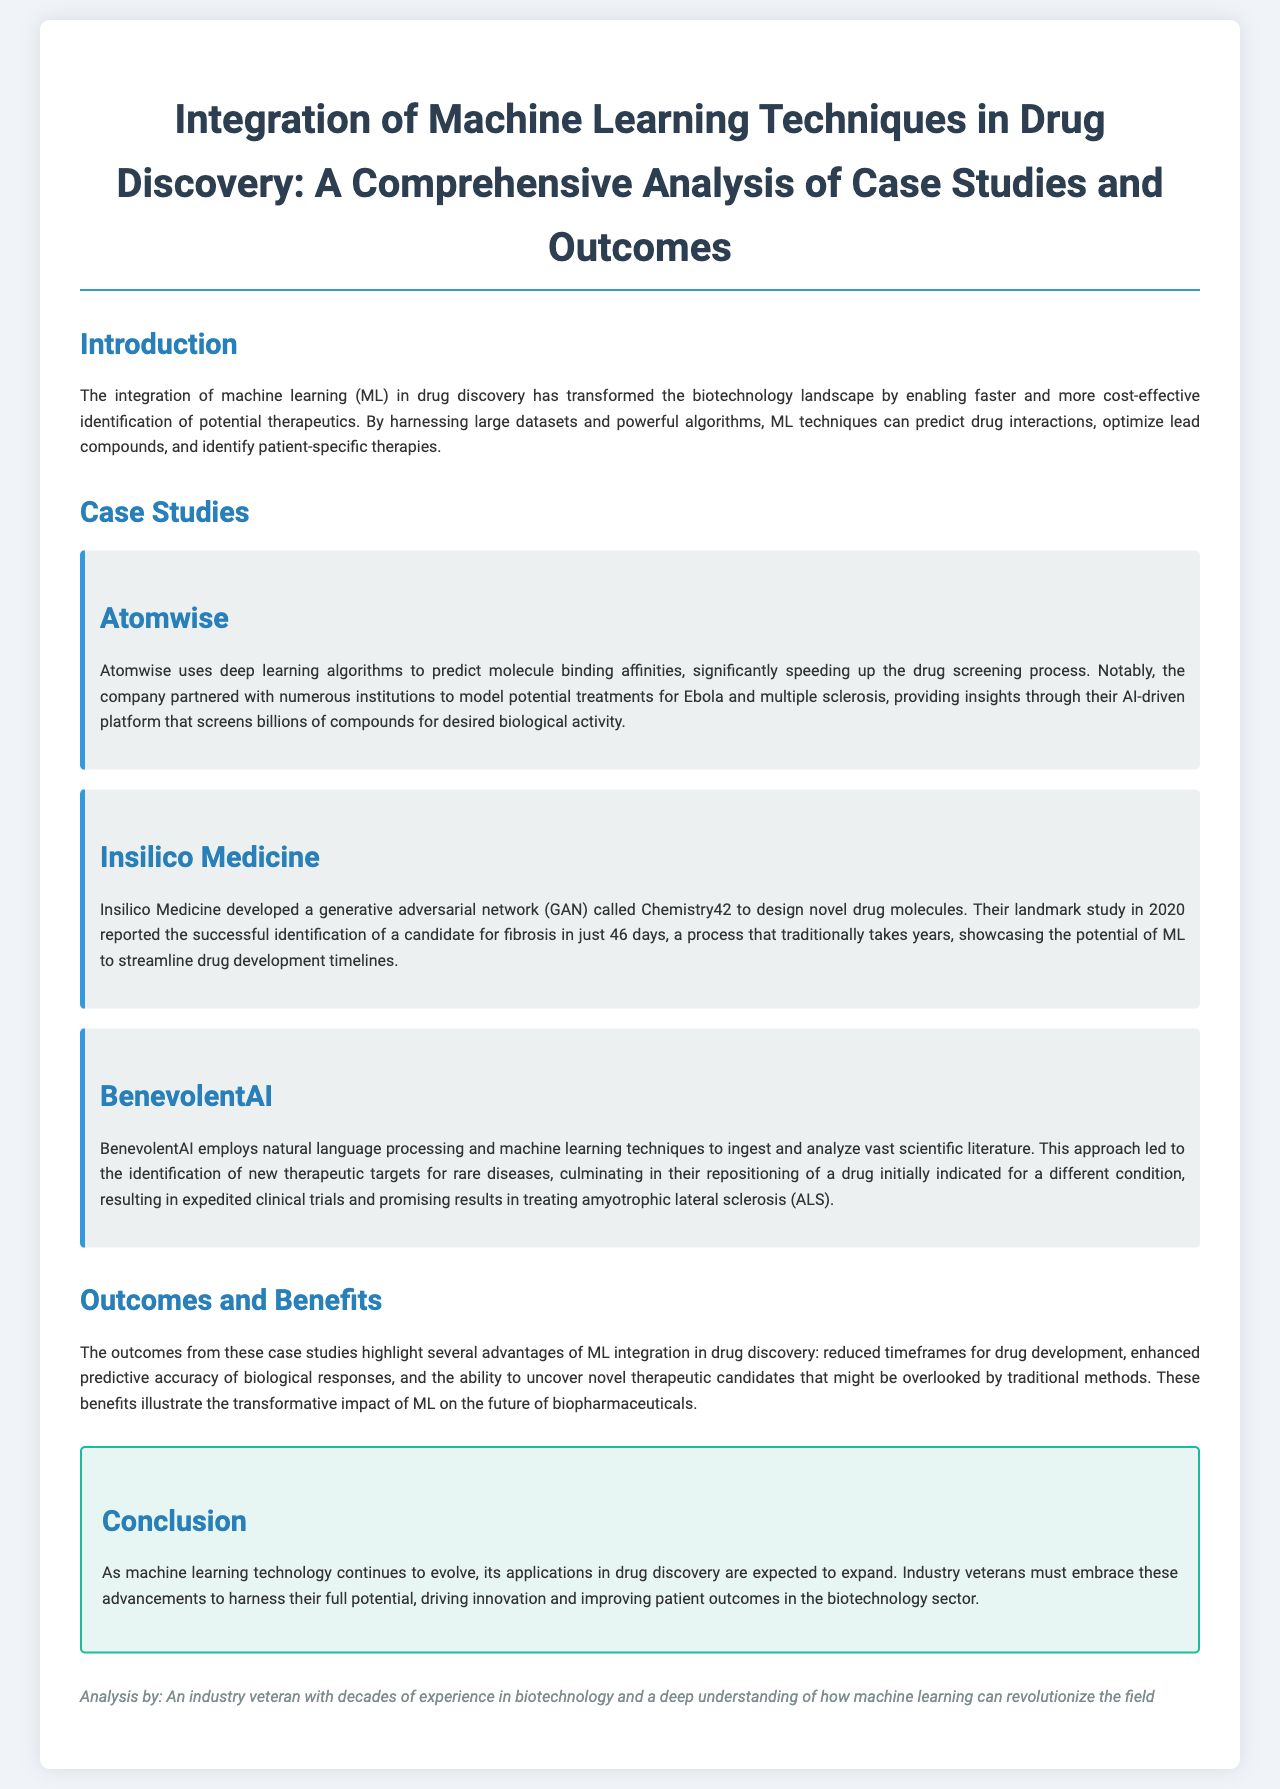What is the title of the report? The title is presented prominently at the beginning of the document and summarizes the content.
Answer: Integration of Machine Learning Techniques in Drug Discovery: A Comprehensive Analysis of Case Studies and Outcomes Which company developed a generative adversarial network called Chemistry42? The document identifies Insilico Medicine as the developer of this technology for drug design.
Answer: Insilico Medicine What disease was targeted by Atomwise's AI-driven platform? Atomwise's platform was notably used for modeling potential treatments for Ebola and multiple sclerosis.
Answer: Ebola and multiple sclerosis How long did it take Insilico Medicine to identify a candidate for fibrosis? This information is mentioned in the context of their significant achievement in drug identification speed.
Answer: 46 days What is one of the main benefits of integrating ML in drug discovery according to the document? The document outlines various advantages, including reduced timeframes for drug development.
Answer: Reduced timeframes for drug development What type of techniques does BenevolentAI use to analyze scientific literature? The document specifies that BenevolentAI employs natural language processing as part of its approach.
Answer: Natural language processing What is a key outcome from the case studies highlighted in the report? The report summarizes outcomes that showcase enhanced predictive accuracy of biological responses through ML.
Answer: Enhanced predictive accuracy of biological responses What is the conclusion about the future impact of ML in drug discovery? The conclusion emphasizes the expected expansion of ML applications in drug discovery as technology evolves.
Answer: Expected expansion of ML applications in drug discovery 